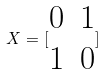Convert formula to latex. <formula><loc_0><loc_0><loc_500><loc_500>X = [ \begin{matrix} 0 & 1 \\ 1 & 0 \end{matrix} ]</formula> 